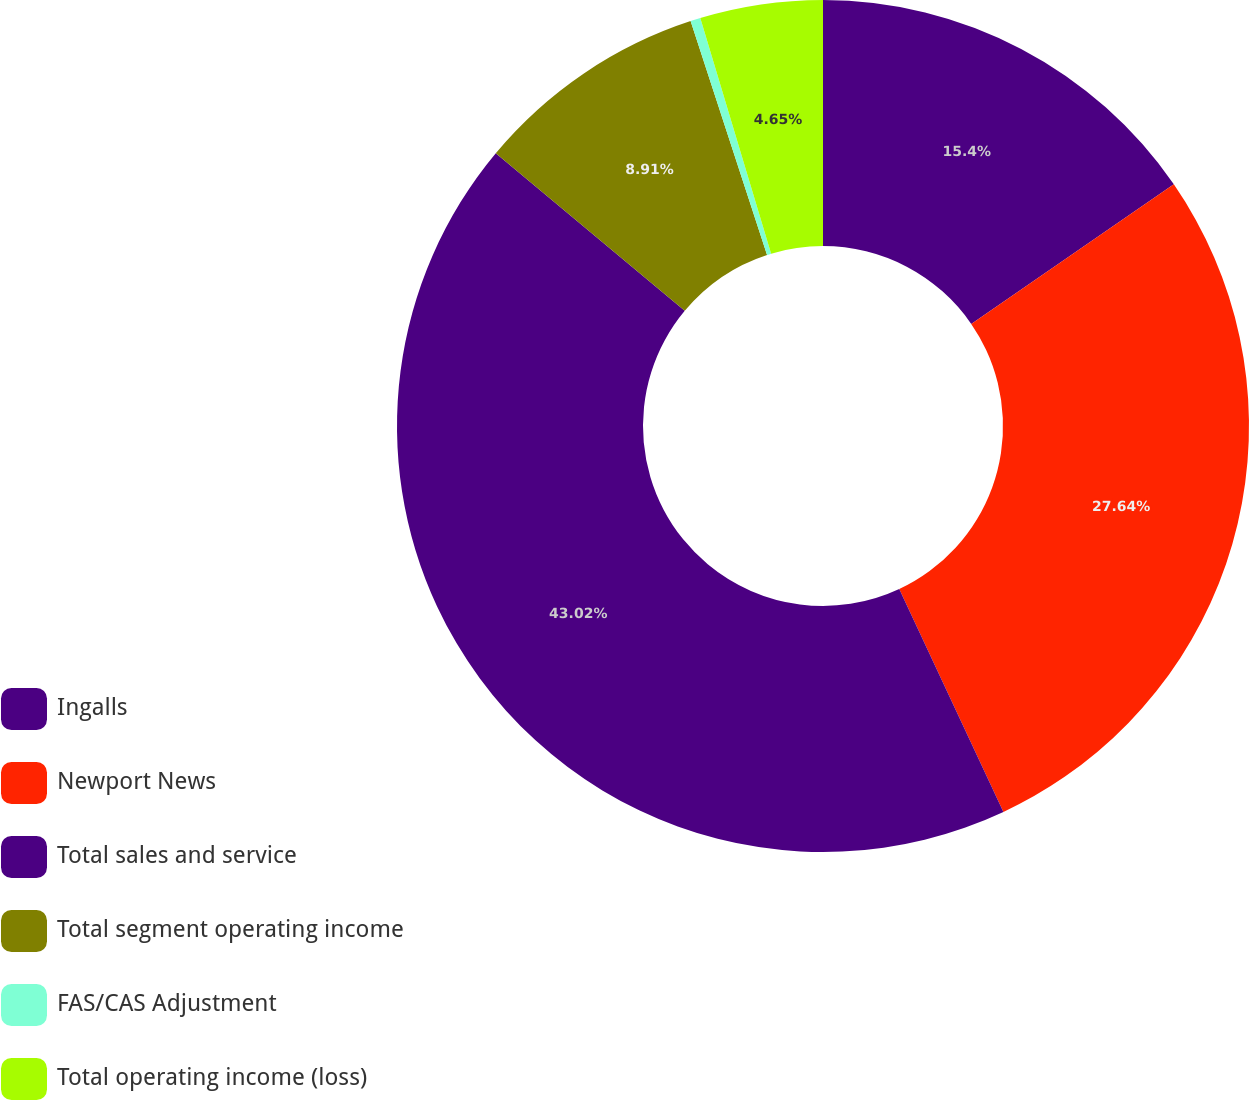<chart> <loc_0><loc_0><loc_500><loc_500><pie_chart><fcel>Ingalls<fcel>Newport News<fcel>Total sales and service<fcel>Total segment operating income<fcel>FAS/CAS Adjustment<fcel>Total operating income (loss)<nl><fcel>15.4%<fcel>27.64%<fcel>43.02%<fcel>8.91%<fcel>0.38%<fcel>4.65%<nl></chart> 